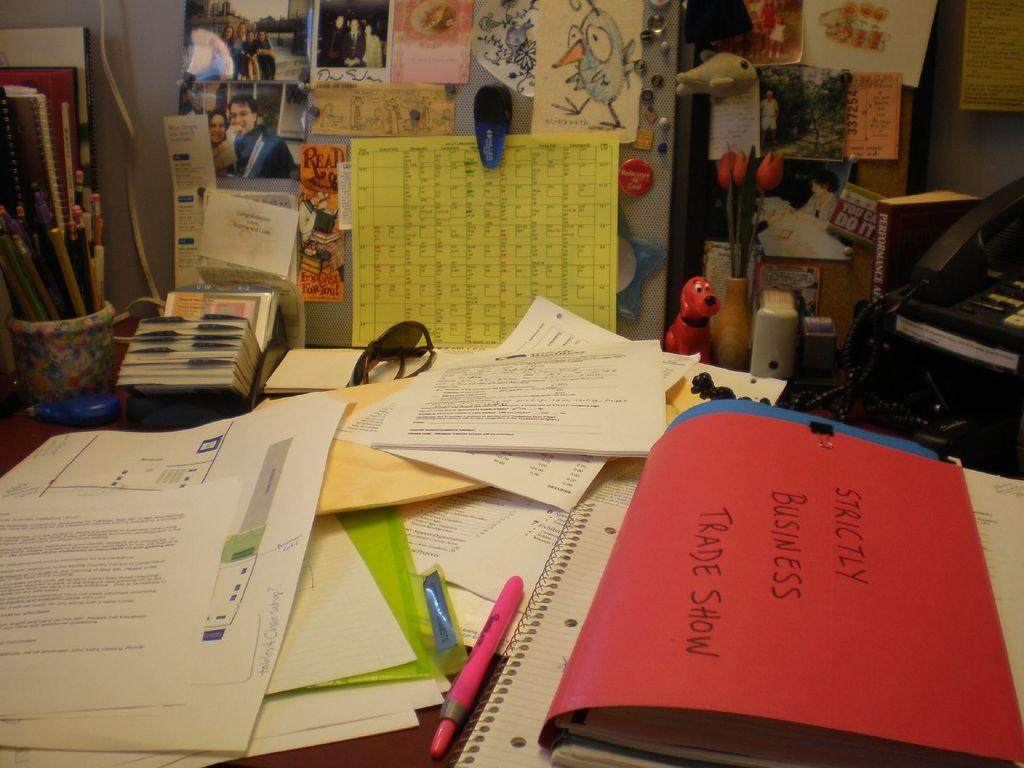<image>
Present a compact description of the photo's key features. A table with many papers on it and a folder that reads Strictly Business Trade Show. 